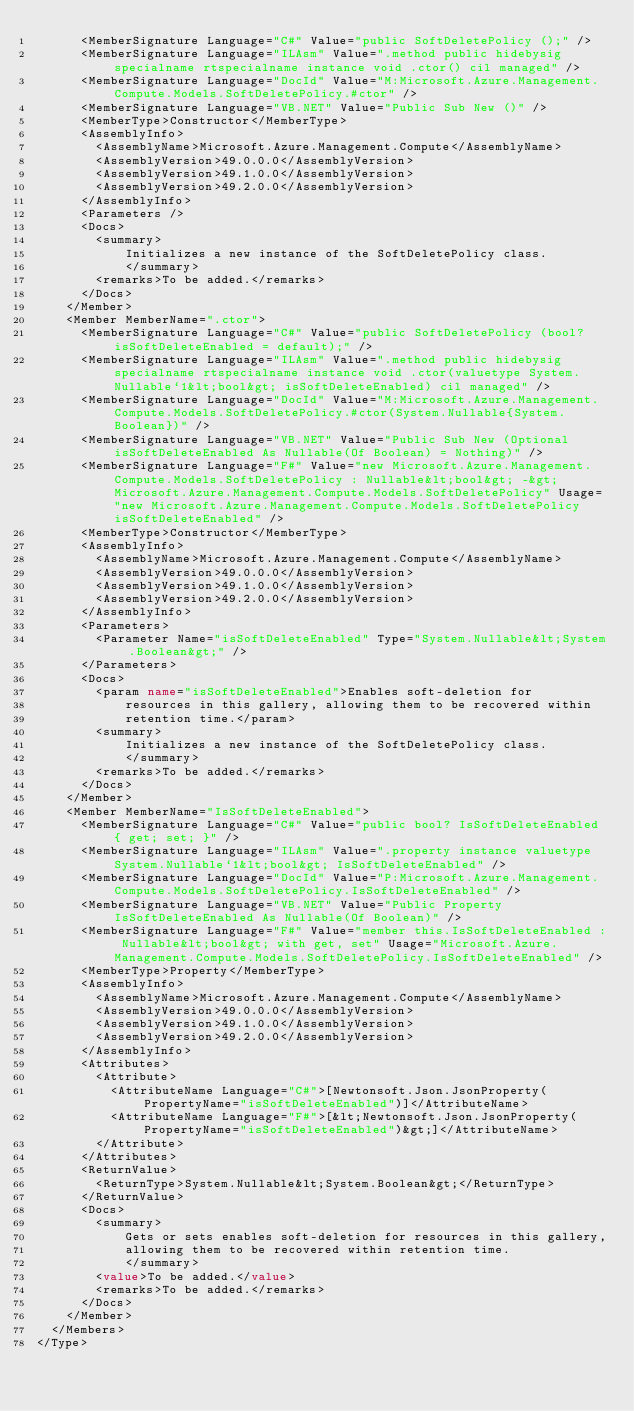Convert code to text. <code><loc_0><loc_0><loc_500><loc_500><_XML_>      <MemberSignature Language="C#" Value="public SoftDeletePolicy ();" />
      <MemberSignature Language="ILAsm" Value=".method public hidebysig specialname rtspecialname instance void .ctor() cil managed" />
      <MemberSignature Language="DocId" Value="M:Microsoft.Azure.Management.Compute.Models.SoftDeletePolicy.#ctor" />
      <MemberSignature Language="VB.NET" Value="Public Sub New ()" />
      <MemberType>Constructor</MemberType>
      <AssemblyInfo>
        <AssemblyName>Microsoft.Azure.Management.Compute</AssemblyName>
        <AssemblyVersion>49.0.0.0</AssemblyVersion>
        <AssemblyVersion>49.1.0.0</AssemblyVersion>
        <AssemblyVersion>49.2.0.0</AssemblyVersion>
      </AssemblyInfo>
      <Parameters />
      <Docs>
        <summary>
            Initializes a new instance of the SoftDeletePolicy class.
            </summary>
        <remarks>To be added.</remarks>
      </Docs>
    </Member>
    <Member MemberName=".ctor">
      <MemberSignature Language="C#" Value="public SoftDeletePolicy (bool? isSoftDeleteEnabled = default);" />
      <MemberSignature Language="ILAsm" Value=".method public hidebysig specialname rtspecialname instance void .ctor(valuetype System.Nullable`1&lt;bool&gt; isSoftDeleteEnabled) cil managed" />
      <MemberSignature Language="DocId" Value="M:Microsoft.Azure.Management.Compute.Models.SoftDeletePolicy.#ctor(System.Nullable{System.Boolean})" />
      <MemberSignature Language="VB.NET" Value="Public Sub New (Optional isSoftDeleteEnabled As Nullable(Of Boolean) = Nothing)" />
      <MemberSignature Language="F#" Value="new Microsoft.Azure.Management.Compute.Models.SoftDeletePolicy : Nullable&lt;bool&gt; -&gt; Microsoft.Azure.Management.Compute.Models.SoftDeletePolicy" Usage="new Microsoft.Azure.Management.Compute.Models.SoftDeletePolicy isSoftDeleteEnabled" />
      <MemberType>Constructor</MemberType>
      <AssemblyInfo>
        <AssemblyName>Microsoft.Azure.Management.Compute</AssemblyName>
        <AssemblyVersion>49.0.0.0</AssemblyVersion>
        <AssemblyVersion>49.1.0.0</AssemblyVersion>
        <AssemblyVersion>49.2.0.0</AssemblyVersion>
      </AssemblyInfo>
      <Parameters>
        <Parameter Name="isSoftDeleteEnabled" Type="System.Nullable&lt;System.Boolean&gt;" />
      </Parameters>
      <Docs>
        <param name="isSoftDeleteEnabled">Enables soft-deletion for
            resources in this gallery, allowing them to be recovered within
            retention time.</param>
        <summary>
            Initializes a new instance of the SoftDeletePolicy class.
            </summary>
        <remarks>To be added.</remarks>
      </Docs>
    </Member>
    <Member MemberName="IsSoftDeleteEnabled">
      <MemberSignature Language="C#" Value="public bool? IsSoftDeleteEnabled { get; set; }" />
      <MemberSignature Language="ILAsm" Value=".property instance valuetype System.Nullable`1&lt;bool&gt; IsSoftDeleteEnabled" />
      <MemberSignature Language="DocId" Value="P:Microsoft.Azure.Management.Compute.Models.SoftDeletePolicy.IsSoftDeleteEnabled" />
      <MemberSignature Language="VB.NET" Value="Public Property IsSoftDeleteEnabled As Nullable(Of Boolean)" />
      <MemberSignature Language="F#" Value="member this.IsSoftDeleteEnabled : Nullable&lt;bool&gt; with get, set" Usage="Microsoft.Azure.Management.Compute.Models.SoftDeletePolicy.IsSoftDeleteEnabled" />
      <MemberType>Property</MemberType>
      <AssemblyInfo>
        <AssemblyName>Microsoft.Azure.Management.Compute</AssemblyName>
        <AssemblyVersion>49.0.0.0</AssemblyVersion>
        <AssemblyVersion>49.1.0.0</AssemblyVersion>
        <AssemblyVersion>49.2.0.0</AssemblyVersion>
      </AssemblyInfo>
      <Attributes>
        <Attribute>
          <AttributeName Language="C#">[Newtonsoft.Json.JsonProperty(PropertyName="isSoftDeleteEnabled")]</AttributeName>
          <AttributeName Language="F#">[&lt;Newtonsoft.Json.JsonProperty(PropertyName="isSoftDeleteEnabled")&gt;]</AttributeName>
        </Attribute>
      </Attributes>
      <ReturnValue>
        <ReturnType>System.Nullable&lt;System.Boolean&gt;</ReturnType>
      </ReturnValue>
      <Docs>
        <summary>
            Gets or sets enables soft-deletion for resources in this gallery,
            allowing them to be recovered within retention time.
            </summary>
        <value>To be added.</value>
        <remarks>To be added.</remarks>
      </Docs>
    </Member>
  </Members>
</Type>
</code> 